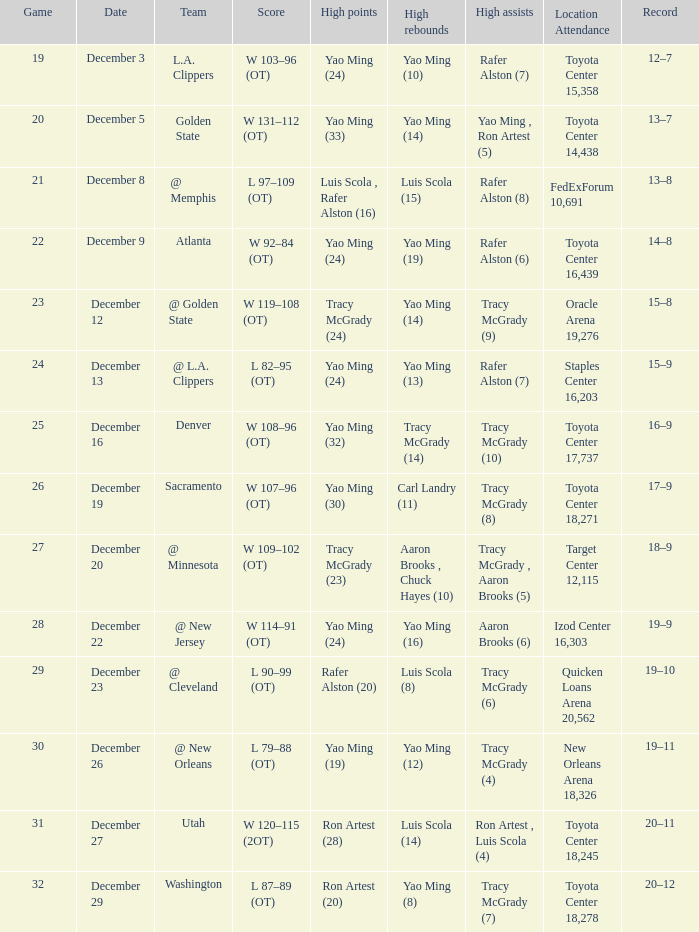On which date did aaron brooks (6) achieve his highest number of assists? December 22. 